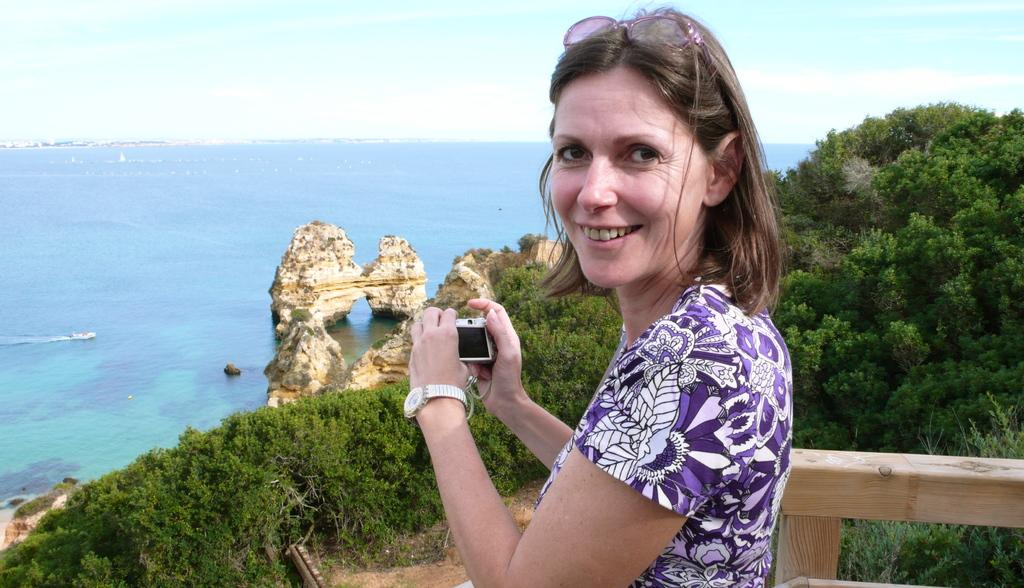Who is present in the image? There is a woman in the image. What is the woman doing in the image? The woman is standing and smiling. What is the woman wearing in the image? The woman is wearing a purple dress. What can be seen on the left side of the image? There is a beach on the left side of the image. What can be seen on the right side of the image? There are trees on the right side of the image. Can you see a tiger pulling a slope in the image? No, there is no tiger or slope present in the image. 